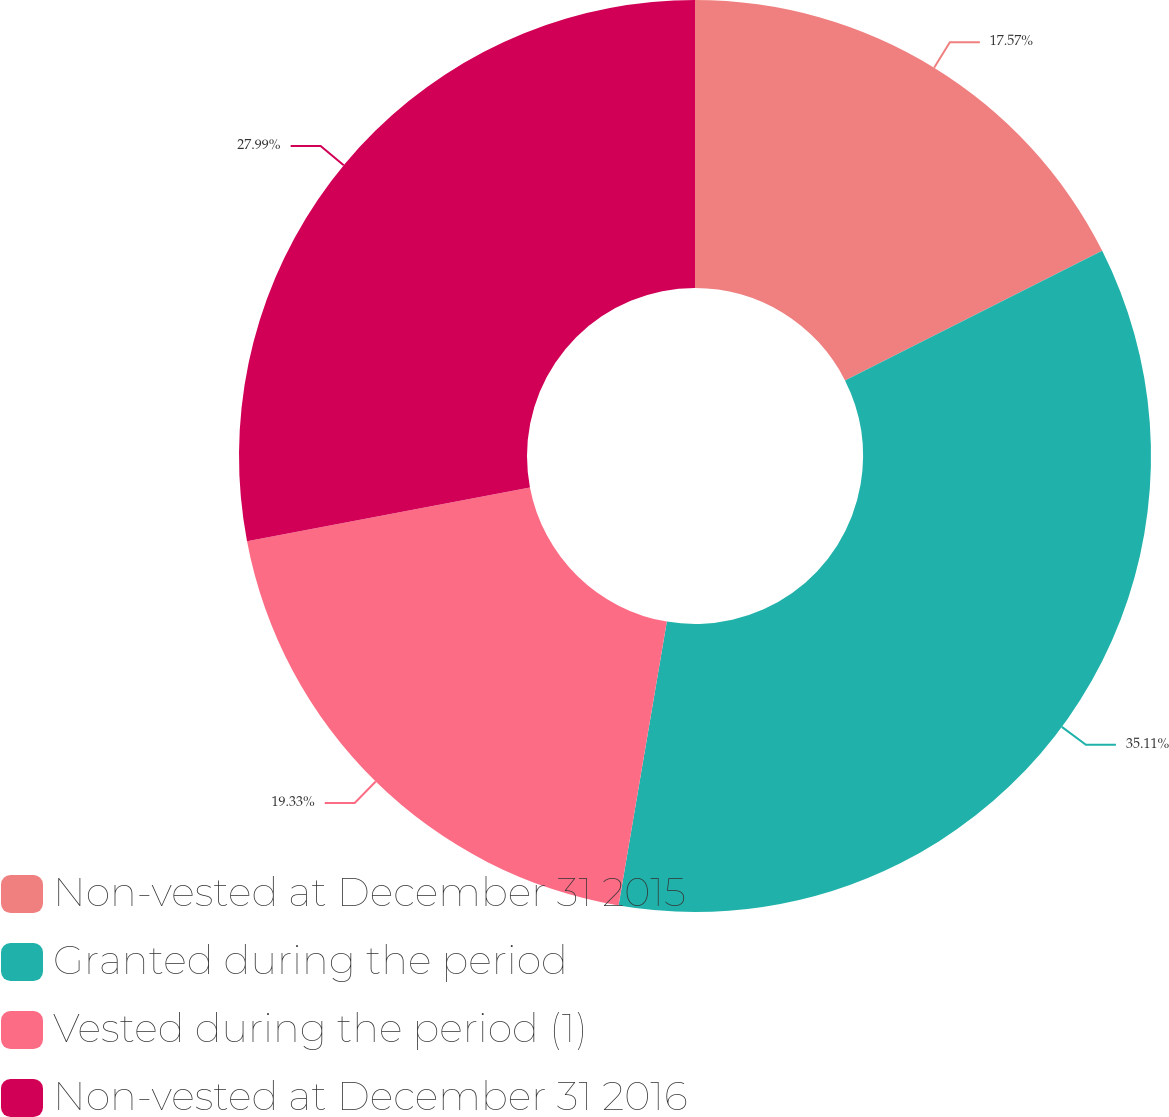Convert chart to OTSL. <chart><loc_0><loc_0><loc_500><loc_500><pie_chart><fcel>Non-vested at December 31 2015<fcel>Granted during the period<fcel>Vested during the period (1)<fcel>Non-vested at December 31 2016<nl><fcel>17.57%<fcel>35.11%<fcel>19.33%<fcel>27.99%<nl></chart> 